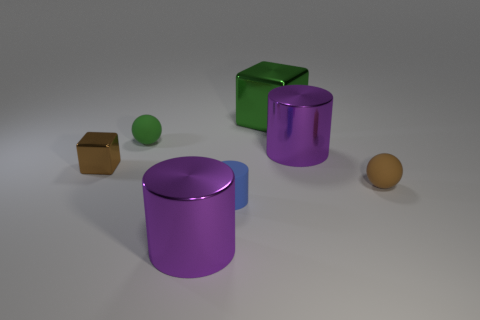Are there any large purple metallic objects behind the tiny cylinder?
Make the answer very short. Yes. What number of brown blocks have the same material as the green cube?
Give a very brief answer. 1. How many objects are small green cylinders or green objects?
Offer a very short reply. 2. Are any small matte objects visible?
Your response must be concise. Yes. There is a small ball behind the large purple thing behind the big purple cylinder in front of the brown block; what is its material?
Offer a very short reply. Rubber. Are there fewer blue objects in front of the brown metal thing than large purple metallic cylinders?
Ensure brevity in your answer.  Yes. There is a blue thing that is the same size as the brown block; what is its material?
Provide a succinct answer. Rubber. There is a object that is both left of the small blue matte cylinder and in front of the brown rubber ball; what is its size?
Ensure brevity in your answer.  Large. There is another thing that is the same shape as the tiny brown metal object; what size is it?
Your answer should be very brief. Large. How many objects are either large brown things or shiny objects behind the small blue thing?
Your answer should be very brief. 3. 